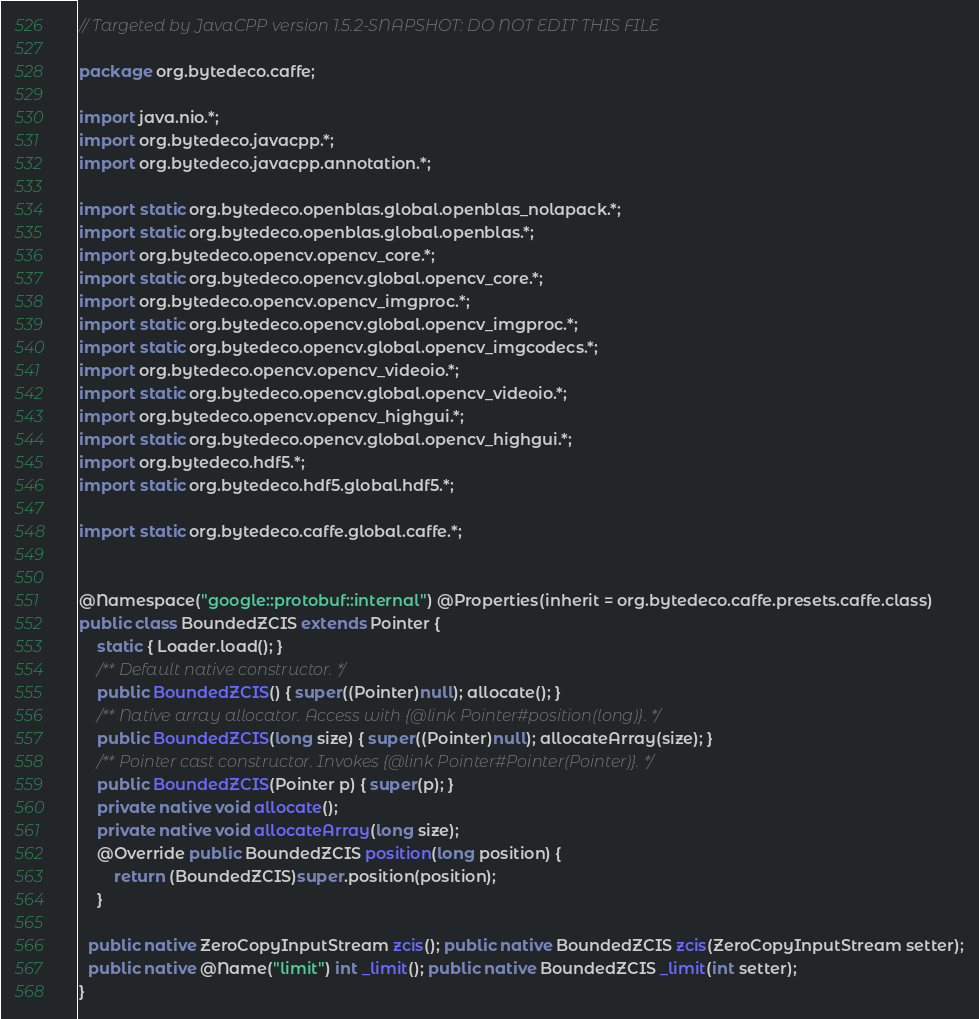Convert code to text. <code><loc_0><loc_0><loc_500><loc_500><_Java_>// Targeted by JavaCPP version 1.5.2-SNAPSHOT: DO NOT EDIT THIS FILE

package org.bytedeco.caffe;

import java.nio.*;
import org.bytedeco.javacpp.*;
import org.bytedeco.javacpp.annotation.*;

import static org.bytedeco.openblas.global.openblas_nolapack.*;
import static org.bytedeco.openblas.global.openblas.*;
import org.bytedeco.opencv.opencv_core.*;
import static org.bytedeco.opencv.global.opencv_core.*;
import org.bytedeco.opencv.opencv_imgproc.*;
import static org.bytedeco.opencv.global.opencv_imgproc.*;
import static org.bytedeco.opencv.global.opencv_imgcodecs.*;
import org.bytedeco.opencv.opencv_videoio.*;
import static org.bytedeco.opencv.global.opencv_videoio.*;
import org.bytedeco.opencv.opencv_highgui.*;
import static org.bytedeco.opencv.global.opencv_highgui.*;
import org.bytedeco.hdf5.*;
import static org.bytedeco.hdf5.global.hdf5.*;

import static org.bytedeco.caffe.global.caffe.*;


@Namespace("google::protobuf::internal") @Properties(inherit = org.bytedeco.caffe.presets.caffe.class)
public class BoundedZCIS extends Pointer {
    static { Loader.load(); }
    /** Default native constructor. */
    public BoundedZCIS() { super((Pointer)null); allocate(); }
    /** Native array allocator. Access with {@link Pointer#position(long)}. */
    public BoundedZCIS(long size) { super((Pointer)null); allocateArray(size); }
    /** Pointer cast constructor. Invokes {@link Pointer#Pointer(Pointer)}. */
    public BoundedZCIS(Pointer p) { super(p); }
    private native void allocate();
    private native void allocateArray(long size);
    @Override public BoundedZCIS position(long position) {
        return (BoundedZCIS)super.position(position);
    }

  public native ZeroCopyInputStream zcis(); public native BoundedZCIS zcis(ZeroCopyInputStream setter);
  public native @Name("limit") int _limit(); public native BoundedZCIS _limit(int setter);
}
</code> 